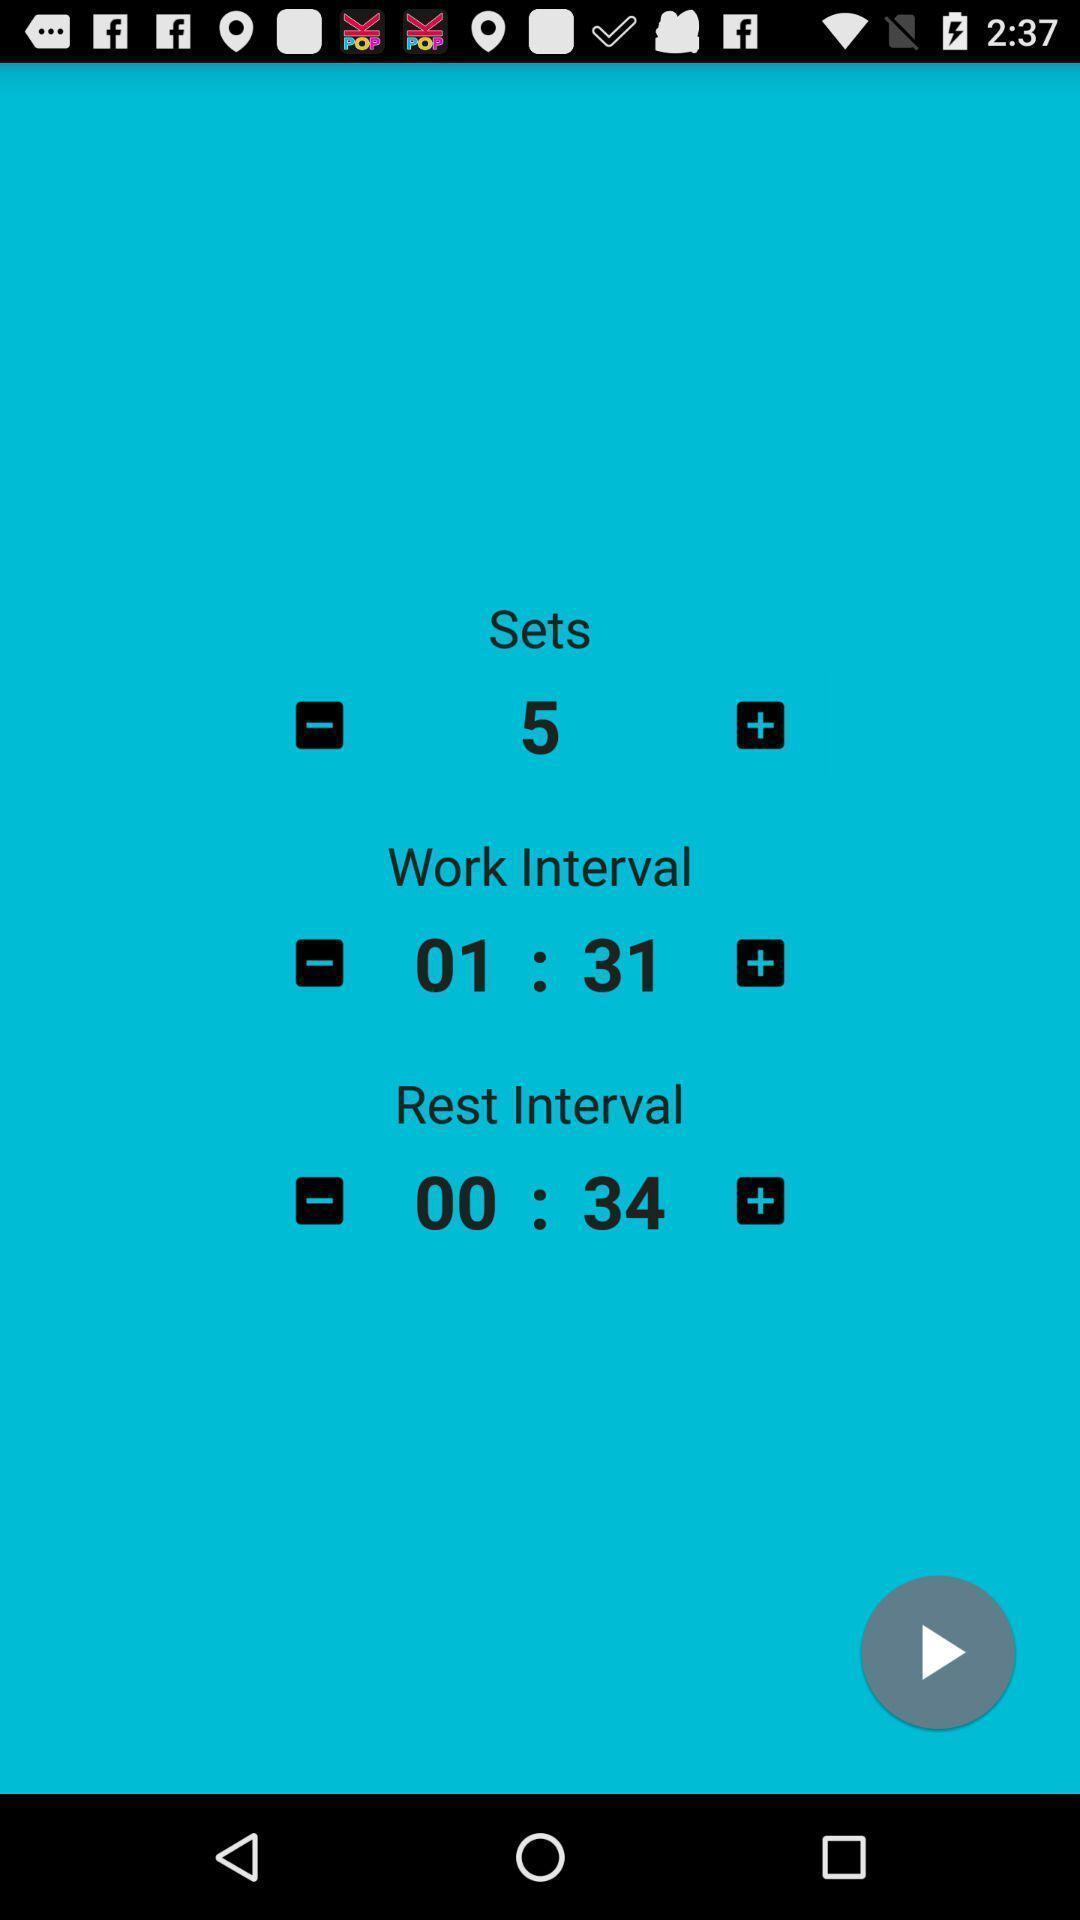Describe the visual elements of this screenshot. Page displaying to set-up time in a scheduling app. 